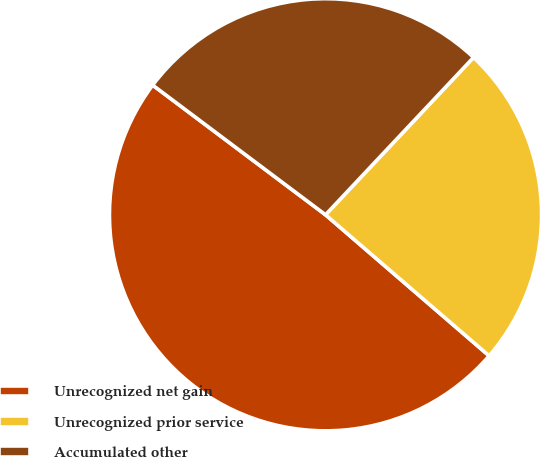Convert chart. <chart><loc_0><loc_0><loc_500><loc_500><pie_chart><fcel>Unrecognized net gain<fcel>Unrecognized prior service<fcel>Accumulated other<nl><fcel>48.92%<fcel>24.31%<fcel>26.77%<nl></chart> 